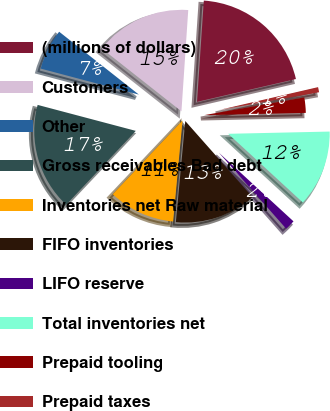Convert chart to OTSL. <chart><loc_0><loc_0><loc_500><loc_500><pie_chart><fcel>(millions of dollars)<fcel>Customers<fcel>Other<fcel>Gross receivables Bad debt<fcel>Inventories net Raw material<fcel>FIFO inventories<fcel>LIFO reserve<fcel>Total inventories net<fcel>Prepaid tooling<fcel>Prepaid taxes<nl><fcel>20.32%<fcel>15.44%<fcel>6.51%<fcel>17.07%<fcel>10.57%<fcel>13.01%<fcel>1.63%<fcel>12.19%<fcel>2.44%<fcel>0.82%<nl></chart> 